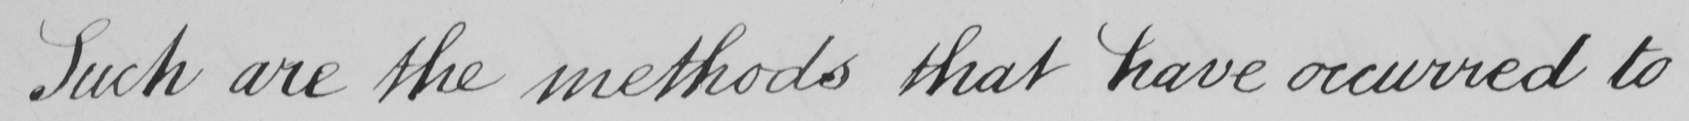Can you read and transcribe this handwriting? Such are the methods that have occurred to 